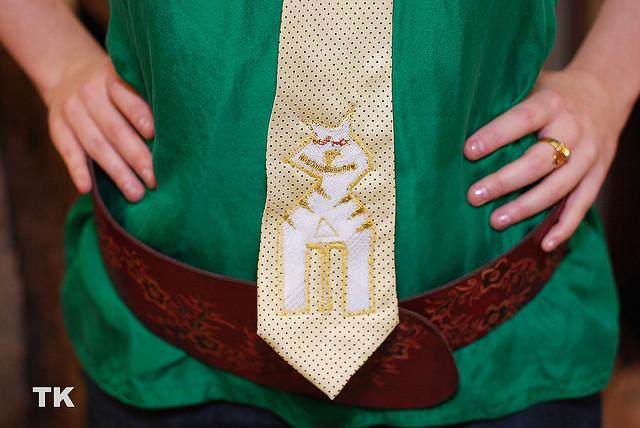What gemstone is in her ring?
Give a very brief answer. Amethyst. What color is the shirt?
Concise answer only. Green. What is embroidered on the shirt?
Concise answer only. Cat. 